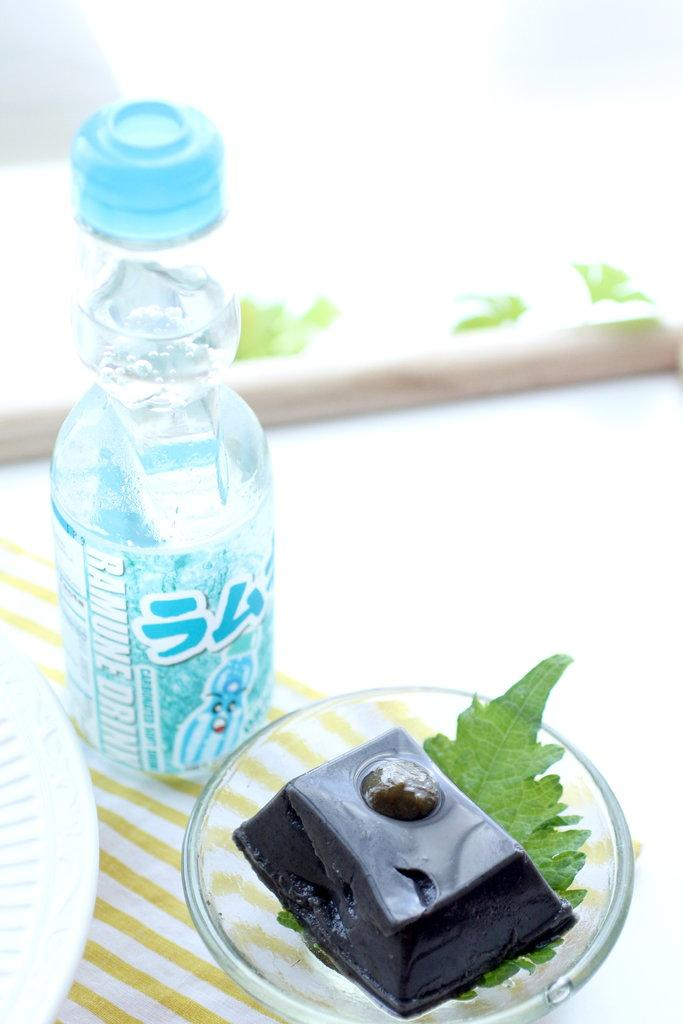What type of container is visible in the image? There is a water bottle in the image. What color is the water bottle? The water bottle is blue. What other objects can be seen in the image? There is a plate and a bowl in the image. What is inside the bowl? There are eatables in the bowl. Where is the basketball located in the image? There is no basketball present in the image. What type of jar is visible in the image? There is no jar present in the image. 